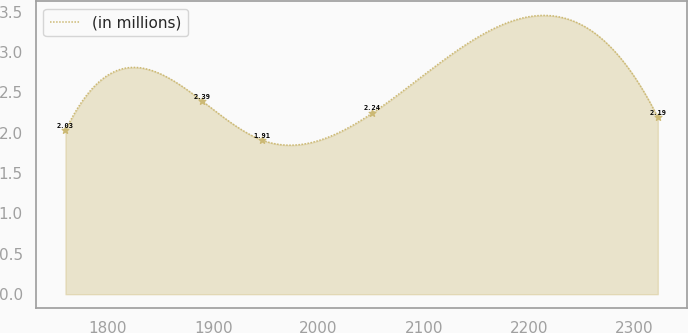Convert chart. <chart><loc_0><loc_0><loc_500><loc_500><line_chart><ecel><fcel>(in millions)<nl><fcel>1759.73<fcel>2.03<nl><fcel>1889.8<fcel>2.39<nl><fcel>1946.02<fcel>1.91<nl><fcel>2050.55<fcel>2.24<nl><fcel>2321.98<fcel>2.19<nl></chart> 